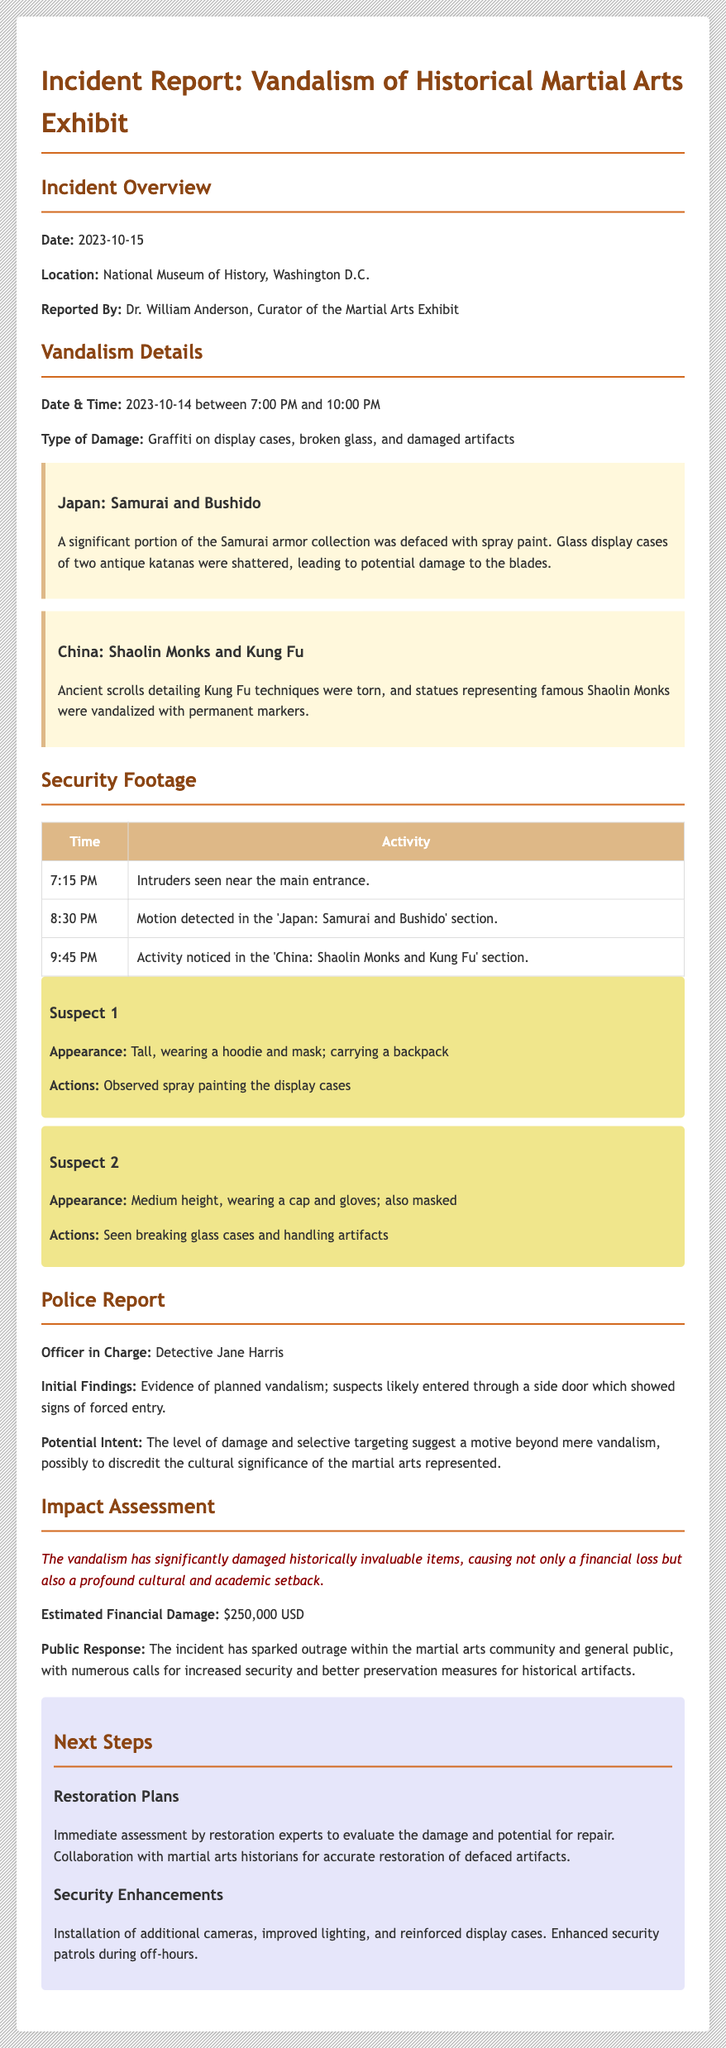What is the date of the incident? The date of the incident is found in the Incident Overview section of the document.
Answer: 2023-10-15 What type of damage occurred? The document lists the types of damage in the Vandalism Details section.
Answer: Graffiti on display cases, broken glass, and damaged artifacts Who reported the incident? The report identifies the person who reported the incident in the Incident Overview section.
Answer: Dr. William Anderson What was the estimated financial damage? The estimated financial damage is provided in the Impact Assessment section.
Answer: $250,000 USD What did the police report suggest about the vandalism? The police report section mentions findings regarding the nature of the vandalism.
Answer: Planned vandalism How many suspects were identified in the security footage? The security footage section highlights the number of suspects seen during the incident.
Answer: Two What specific artifacts were damaged in the Japan section? The Vandalism Details section specifies which artifacts were affected in the Japan section.
Answer: Samurai armor and antique katanas What is one of the public responses to the vandalism? The Impact Assessment section notes the public response to the incident.
Answer: Outrage within the martial arts community What kind of enhancements are planned for security? The Next Steps section describes the planned security improvements.
Answer: Installation of additional cameras, improved lighting, and reinforced display cases 